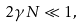Convert formula to latex. <formula><loc_0><loc_0><loc_500><loc_500>2 \gamma N \ll 1 ,</formula> 